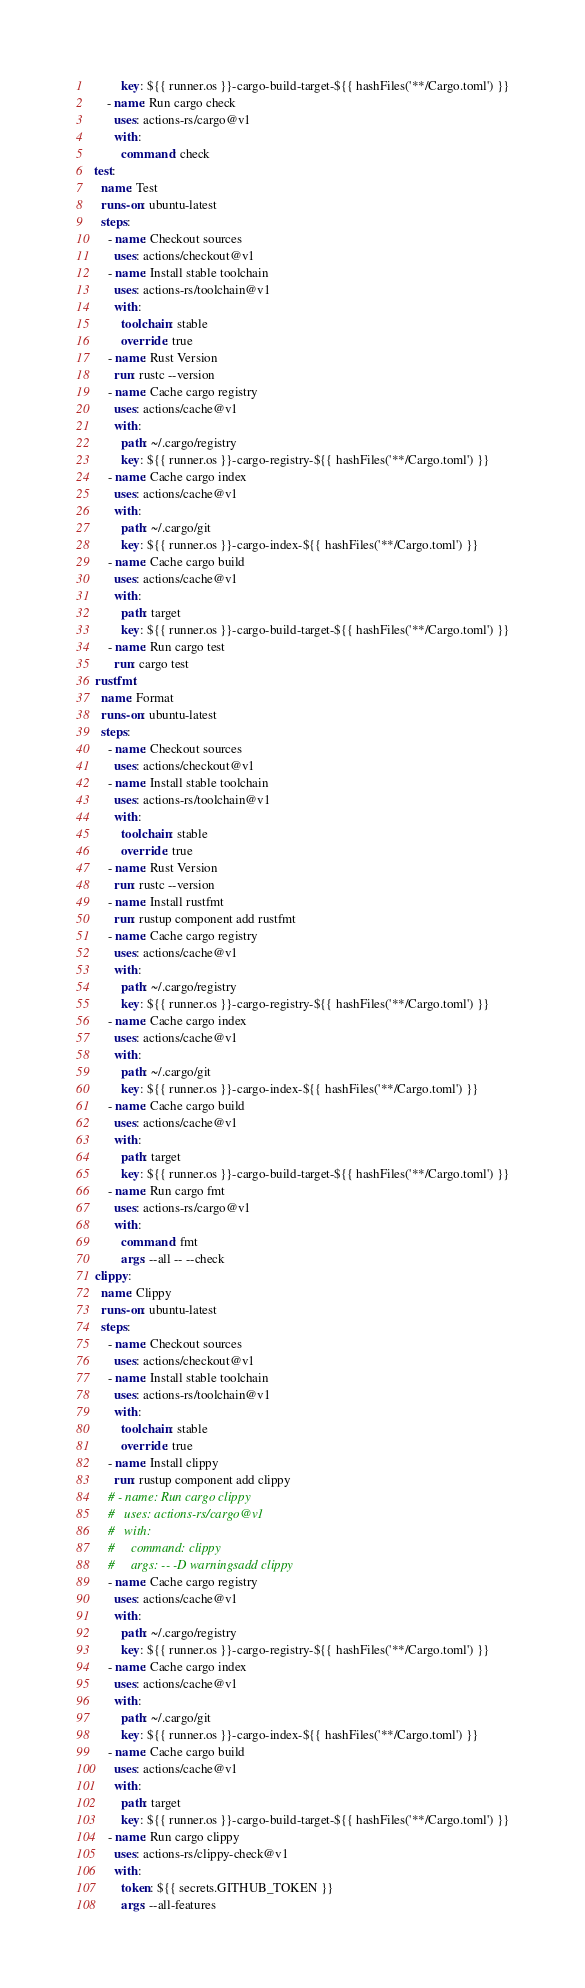Convert code to text. <code><loc_0><loc_0><loc_500><loc_500><_YAML_>          key: ${{ runner.os }}-cargo-build-target-${{ hashFiles('**/Cargo.toml') }}
      - name: Run cargo check
        uses: actions-rs/cargo@v1
        with:
          command: check
  test:
    name: Test
    runs-on: ubuntu-latest
    steps:
      - name: Checkout sources
        uses: actions/checkout@v1
      - name: Install stable toolchain
        uses: actions-rs/toolchain@v1
        with:
          toolchain: stable
          override: true
      - name: Rust Version
        run: rustc --version
      - name: Cache cargo registry
        uses: actions/cache@v1
        with:
          path: ~/.cargo/registry
          key: ${{ runner.os }}-cargo-registry-${{ hashFiles('**/Cargo.toml') }}
      - name: Cache cargo index
        uses: actions/cache@v1
        with:
          path: ~/.cargo/git
          key: ${{ runner.os }}-cargo-index-${{ hashFiles('**/Cargo.toml') }}
      - name: Cache cargo build
        uses: actions/cache@v1
        with:
          path: target
          key: ${{ runner.os }}-cargo-build-target-${{ hashFiles('**/Cargo.toml') }}
      - name: Run cargo test
        run: cargo test
  rustfmt:
    name: Format
    runs-on: ubuntu-latest
    steps:
      - name: Checkout sources
        uses: actions/checkout@v1
      - name: Install stable toolchain
        uses: actions-rs/toolchain@v1
        with:
          toolchain: stable
          override: true
      - name: Rust Version
        run: rustc --version
      - name: Install rustfmt
        run: rustup component add rustfmt
      - name: Cache cargo registry
        uses: actions/cache@v1
        with:
          path: ~/.cargo/registry
          key: ${{ runner.os }}-cargo-registry-${{ hashFiles('**/Cargo.toml') }}
      - name: Cache cargo index
        uses: actions/cache@v1
        with:
          path: ~/.cargo/git
          key: ${{ runner.os }}-cargo-index-${{ hashFiles('**/Cargo.toml') }}
      - name: Cache cargo build
        uses: actions/cache@v1
        with:
          path: target
          key: ${{ runner.os }}-cargo-build-target-${{ hashFiles('**/Cargo.toml') }}
      - name: Run cargo fmt
        uses: actions-rs/cargo@v1
        with:
          command: fmt
          args: --all -- --check
  clippy:
    name: Clippy
    runs-on: ubuntu-latest
    steps:
      - name: Checkout sources
        uses: actions/checkout@v1
      - name: Install stable toolchain
        uses: actions-rs/toolchain@v1
        with:
          toolchain: stable
          override: true
      - name: Install clippy
        run: rustup component add clippy
      # - name: Run cargo clippy
      #   uses: actions-rs/cargo@v1
      #   with:
      #     command: clippy
      #     args: -- -D warningsadd clippy
      - name: Cache cargo registry
        uses: actions/cache@v1
        with:
          path: ~/.cargo/registry
          key: ${{ runner.os }}-cargo-registry-${{ hashFiles('**/Cargo.toml') }}
      - name: Cache cargo index
        uses: actions/cache@v1
        with:
          path: ~/.cargo/git
          key: ${{ runner.os }}-cargo-index-${{ hashFiles('**/Cargo.toml') }}
      - name: Cache cargo build
        uses: actions/cache@v1
        with:
          path: target
          key: ${{ runner.os }}-cargo-build-target-${{ hashFiles('**/Cargo.toml') }}
      - name: Run cargo clippy
        uses: actions-rs/clippy-check@v1
        with:
          token: ${{ secrets.GITHUB_TOKEN }}
          args: --all-features
</code> 